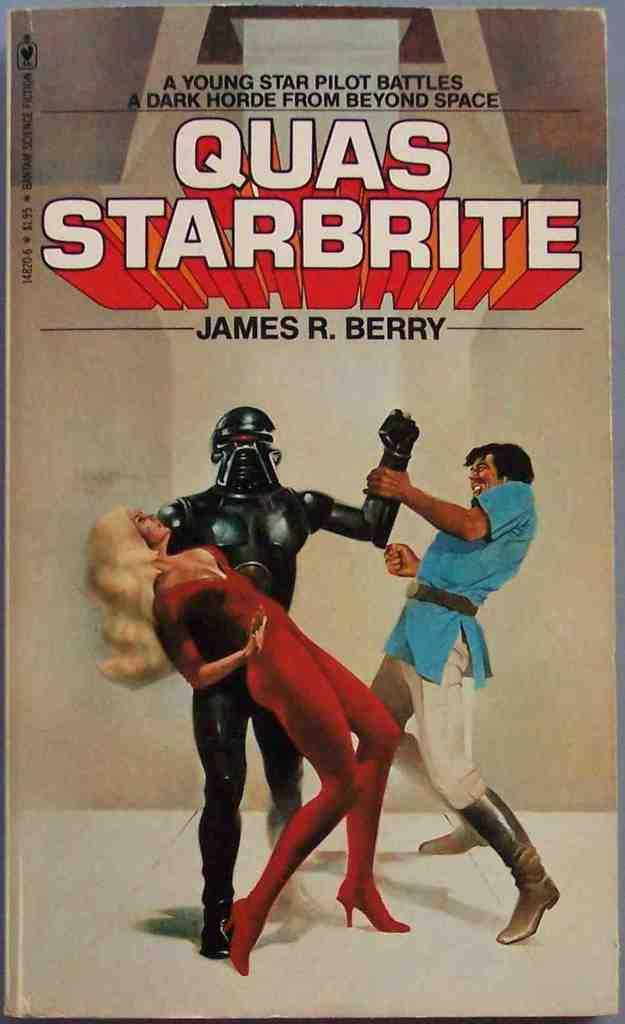What is the main object in the image? There is a poster in the image. What is shown on the poster? The poster depicts people and has text present on it. What committee is responsible for the knowledge displayed on the poster? There is no committee or knowledge mentioned in the image; it only features a poster with people and text. 